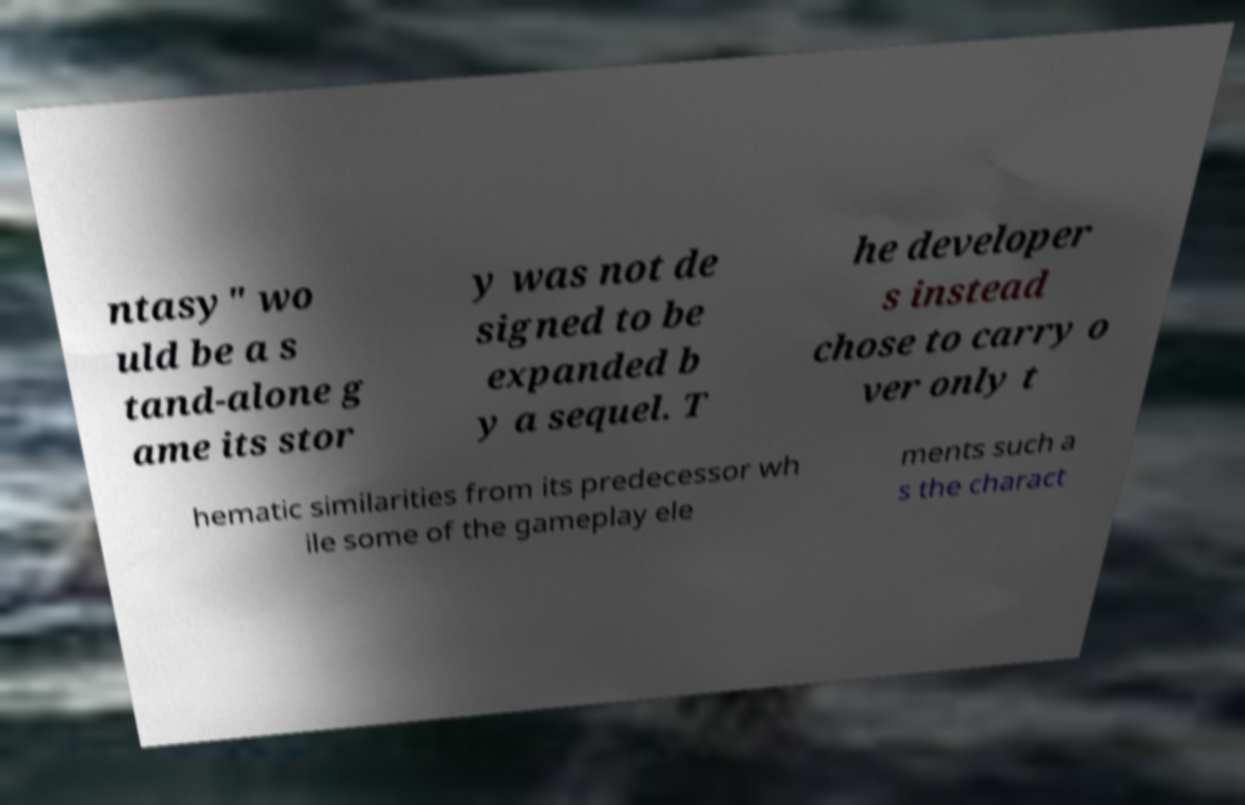Could you assist in decoding the text presented in this image and type it out clearly? ntasy" wo uld be a s tand-alone g ame its stor y was not de signed to be expanded b y a sequel. T he developer s instead chose to carry o ver only t hematic similarities from its predecessor wh ile some of the gameplay ele ments such a s the charact 